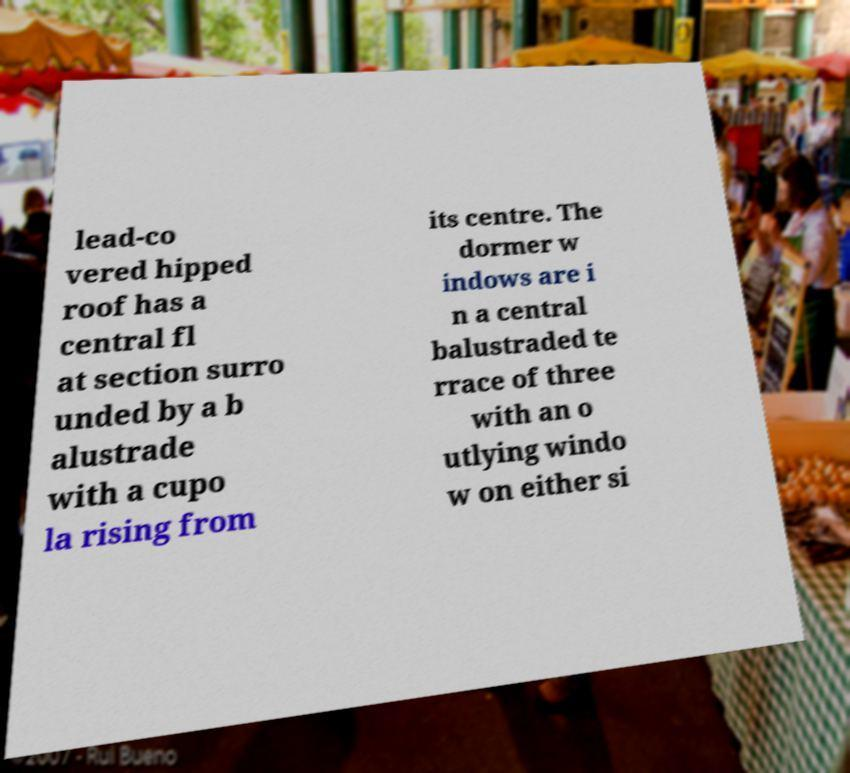There's text embedded in this image that I need extracted. Can you transcribe it verbatim? lead-co vered hipped roof has a central fl at section surro unded by a b alustrade with a cupo la rising from its centre. The dormer w indows are i n a central balustraded te rrace of three with an o utlying windo w on either si 